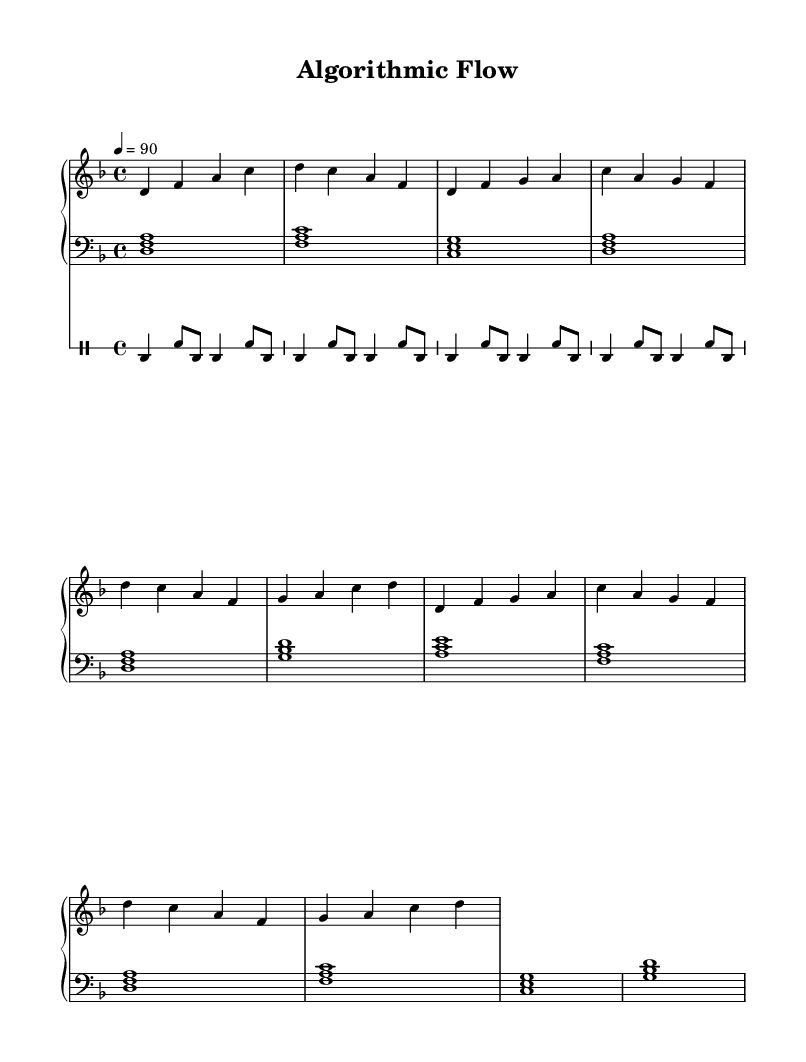What is the key signature of this music? The key signature listed in the global settings indicates the piece is in D minor, which consists of one flat (B flat).
Answer: D minor What is the time signature? The time signature appears in the global settings as 4/4, meaning there are four beats in each measure and the quarter note gets one beat.
Answer: 4/4 What is the tempo marking for the piece? The tempo is specified in the global settings, indicating a speed of 90 beats per minute.
Answer: 90 How many sections are in the structure of this piece? The structure includes an introduction, two verses, and a chorus that repeats, totaling three distinct sections.
Answer: Three Which part has the bass clef? The left hand of the piano part is specifically marked with a bass clef, indicating it plays lower notes compared to the right hand.
Answer: Left hand In which section does the melody first appear? The melody first appears in the introduction, as indicated by the order of the musical phrases.
Answer: Introduction What is the rhythmic pattern of the drum part? The drum part is characterized by a repeated bass drum and snare drum rhythm throughout its section.
Answer: Repeated bass and snare 